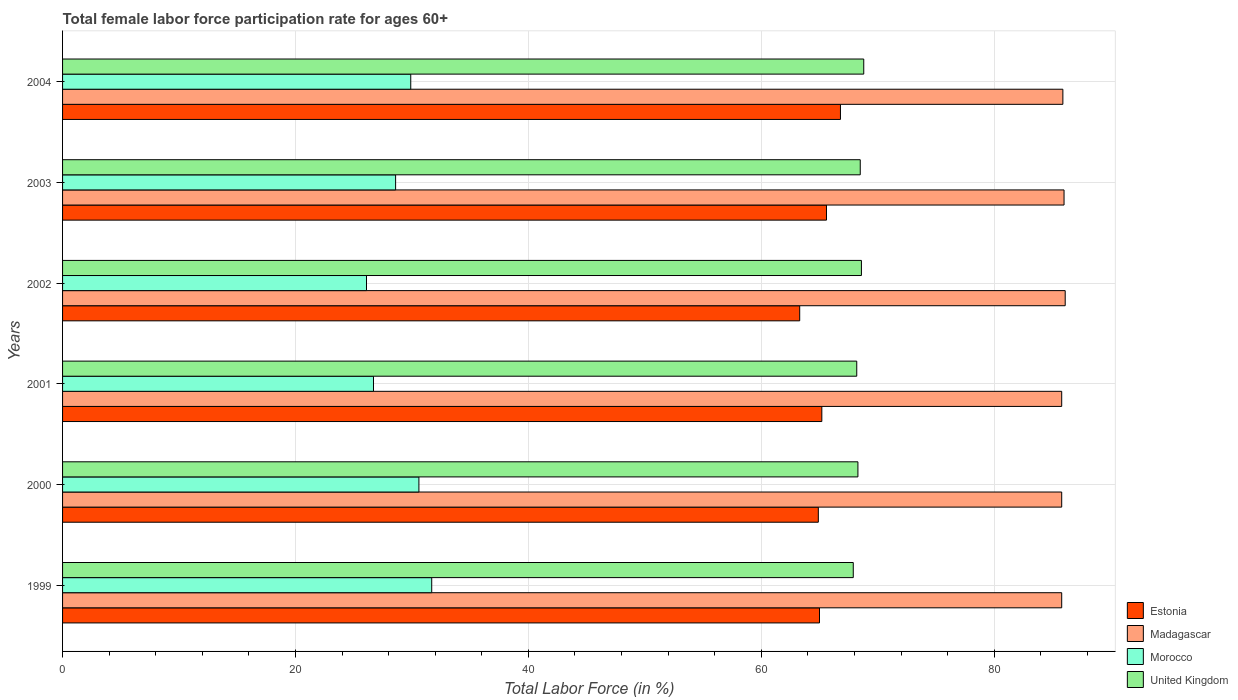Are the number of bars per tick equal to the number of legend labels?
Offer a very short reply. Yes. Are the number of bars on each tick of the Y-axis equal?
Provide a short and direct response. Yes. What is the label of the 5th group of bars from the top?
Your answer should be very brief. 2000. What is the female labor force participation rate in Morocco in 2001?
Your response must be concise. 26.7. Across all years, what is the maximum female labor force participation rate in United Kingdom?
Your answer should be very brief. 68.8. Across all years, what is the minimum female labor force participation rate in Morocco?
Your response must be concise. 26.1. In which year was the female labor force participation rate in Morocco minimum?
Keep it short and to the point. 2002. What is the total female labor force participation rate in Estonia in the graph?
Offer a terse response. 390.8. What is the difference between the female labor force participation rate in Madagascar in 1999 and that in 2003?
Make the answer very short. -0.2. What is the average female labor force participation rate in United Kingdom per year?
Make the answer very short. 68.38. In the year 2000, what is the difference between the female labor force participation rate in Morocco and female labor force participation rate in Madagascar?
Your answer should be very brief. -55.2. What is the ratio of the female labor force participation rate in United Kingdom in 1999 to that in 2000?
Your response must be concise. 0.99. Is the female labor force participation rate in Estonia in 2000 less than that in 2001?
Offer a very short reply. Yes. Is the difference between the female labor force participation rate in Morocco in 2000 and 2003 greater than the difference between the female labor force participation rate in Madagascar in 2000 and 2003?
Your answer should be very brief. Yes. What is the difference between the highest and the second highest female labor force participation rate in Madagascar?
Your answer should be compact. 0.1. What is the difference between the highest and the lowest female labor force participation rate in Morocco?
Ensure brevity in your answer.  5.6. In how many years, is the female labor force participation rate in Morocco greater than the average female labor force participation rate in Morocco taken over all years?
Give a very brief answer. 3. Is it the case that in every year, the sum of the female labor force participation rate in United Kingdom and female labor force participation rate in Madagascar is greater than the sum of female labor force participation rate in Morocco and female labor force participation rate in Estonia?
Provide a short and direct response. No. What does the 3rd bar from the top in 2001 represents?
Provide a short and direct response. Madagascar. What does the 1st bar from the bottom in 1999 represents?
Ensure brevity in your answer.  Estonia. Is it the case that in every year, the sum of the female labor force participation rate in Morocco and female labor force participation rate in United Kingdom is greater than the female labor force participation rate in Madagascar?
Make the answer very short. Yes. How many bars are there?
Your response must be concise. 24. Are all the bars in the graph horizontal?
Offer a terse response. Yes. How many years are there in the graph?
Provide a short and direct response. 6. What is the difference between two consecutive major ticks on the X-axis?
Offer a terse response. 20. Where does the legend appear in the graph?
Your answer should be compact. Bottom right. How many legend labels are there?
Keep it short and to the point. 4. How are the legend labels stacked?
Your response must be concise. Vertical. What is the title of the graph?
Ensure brevity in your answer.  Total female labor force participation rate for ages 60+. Does "Fragile and conflict affected situations" appear as one of the legend labels in the graph?
Give a very brief answer. No. What is the label or title of the X-axis?
Offer a very short reply. Total Labor Force (in %). What is the Total Labor Force (in %) of Estonia in 1999?
Ensure brevity in your answer.  65. What is the Total Labor Force (in %) in Madagascar in 1999?
Give a very brief answer. 85.8. What is the Total Labor Force (in %) of Morocco in 1999?
Provide a succinct answer. 31.7. What is the Total Labor Force (in %) in United Kingdom in 1999?
Keep it short and to the point. 67.9. What is the Total Labor Force (in %) of Estonia in 2000?
Provide a short and direct response. 64.9. What is the Total Labor Force (in %) in Madagascar in 2000?
Provide a succinct answer. 85.8. What is the Total Labor Force (in %) in Morocco in 2000?
Offer a very short reply. 30.6. What is the Total Labor Force (in %) of United Kingdom in 2000?
Give a very brief answer. 68.3. What is the Total Labor Force (in %) in Estonia in 2001?
Make the answer very short. 65.2. What is the Total Labor Force (in %) of Madagascar in 2001?
Your answer should be compact. 85.8. What is the Total Labor Force (in %) in Morocco in 2001?
Offer a terse response. 26.7. What is the Total Labor Force (in %) in United Kingdom in 2001?
Give a very brief answer. 68.2. What is the Total Labor Force (in %) of Estonia in 2002?
Your answer should be compact. 63.3. What is the Total Labor Force (in %) of Madagascar in 2002?
Provide a succinct answer. 86.1. What is the Total Labor Force (in %) of Morocco in 2002?
Your answer should be very brief. 26.1. What is the Total Labor Force (in %) of United Kingdom in 2002?
Provide a succinct answer. 68.6. What is the Total Labor Force (in %) of Estonia in 2003?
Give a very brief answer. 65.6. What is the Total Labor Force (in %) of Madagascar in 2003?
Your answer should be very brief. 86. What is the Total Labor Force (in %) in Morocco in 2003?
Your answer should be compact. 28.6. What is the Total Labor Force (in %) in United Kingdom in 2003?
Provide a succinct answer. 68.5. What is the Total Labor Force (in %) in Estonia in 2004?
Offer a very short reply. 66.8. What is the Total Labor Force (in %) in Madagascar in 2004?
Offer a very short reply. 85.9. What is the Total Labor Force (in %) in Morocco in 2004?
Offer a very short reply. 29.9. What is the Total Labor Force (in %) of United Kingdom in 2004?
Your answer should be very brief. 68.8. Across all years, what is the maximum Total Labor Force (in %) of Estonia?
Offer a very short reply. 66.8. Across all years, what is the maximum Total Labor Force (in %) in Madagascar?
Give a very brief answer. 86.1. Across all years, what is the maximum Total Labor Force (in %) in Morocco?
Keep it short and to the point. 31.7. Across all years, what is the maximum Total Labor Force (in %) in United Kingdom?
Your answer should be compact. 68.8. Across all years, what is the minimum Total Labor Force (in %) in Estonia?
Ensure brevity in your answer.  63.3. Across all years, what is the minimum Total Labor Force (in %) of Madagascar?
Your response must be concise. 85.8. Across all years, what is the minimum Total Labor Force (in %) in Morocco?
Ensure brevity in your answer.  26.1. Across all years, what is the minimum Total Labor Force (in %) in United Kingdom?
Offer a very short reply. 67.9. What is the total Total Labor Force (in %) of Estonia in the graph?
Your answer should be very brief. 390.8. What is the total Total Labor Force (in %) of Madagascar in the graph?
Your response must be concise. 515.4. What is the total Total Labor Force (in %) in Morocco in the graph?
Offer a very short reply. 173.6. What is the total Total Labor Force (in %) of United Kingdom in the graph?
Your answer should be compact. 410.3. What is the difference between the Total Labor Force (in %) in Estonia in 1999 and that in 2000?
Offer a very short reply. 0.1. What is the difference between the Total Labor Force (in %) of Madagascar in 1999 and that in 2000?
Give a very brief answer. 0. What is the difference between the Total Labor Force (in %) in Morocco in 1999 and that in 2000?
Provide a short and direct response. 1.1. What is the difference between the Total Labor Force (in %) of Estonia in 1999 and that in 2002?
Provide a succinct answer. 1.7. What is the difference between the Total Labor Force (in %) of Madagascar in 1999 and that in 2002?
Offer a very short reply. -0.3. What is the difference between the Total Labor Force (in %) of United Kingdom in 1999 and that in 2002?
Offer a very short reply. -0.7. What is the difference between the Total Labor Force (in %) of Estonia in 1999 and that in 2003?
Provide a succinct answer. -0.6. What is the difference between the Total Labor Force (in %) of Madagascar in 1999 and that in 2003?
Ensure brevity in your answer.  -0.2. What is the difference between the Total Labor Force (in %) in Morocco in 1999 and that in 2003?
Your response must be concise. 3.1. What is the difference between the Total Labor Force (in %) of Estonia in 1999 and that in 2004?
Ensure brevity in your answer.  -1.8. What is the difference between the Total Labor Force (in %) in United Kingdom in 1999 and that in 2004?
Your response must be concise. -0.9. What is the difference between the Total Labor Force (in %) in Estonia in 2000 and that in 2001?
Your response must be concise. -0.3. What is the difference between the Total Labor Force (in %) of Madagascar in 2000 and that in 2001?
Your answer should be compact. 0. What is the difference between the Total Labor Force (in %) of Morocco in 2000 and that in 2001?
Provide a succinct answer. 3.9. What is the difference between the Total Labor Force (in %) in Madagascar in 2000 and that in 2002?
Offer a terse response. -0.3. What is the difference between the Total Labor Force (in %) in Morocco in 2000 and that in 2002?
Your response must be concise. 4.5. What is the difference between the Total Labor Force (in %) of United Kingdom in 2000 and that in 2002?
Your answer should be compact. -0.3. What is the difference between the Total Labor Force (in %) in Estonia in 2000 and that in 2003?
Make the answer very short. -0.7. What is the difference between the Total Labor Force (in %) of Madagascar in 2000 and that in 2003?
Ensure brevity in your answer.  -0.2. What is the difference between the Total Labor Force (in %) of Estonia in 2000 and that in 2004?
Offer a terse response. -1.9. What is the difference between the Total Labor Force (in %) of Madagascar in 2000 and that in 2004?
Keep it short and to the point. -0.1. What is the difference between the Total Labor Force (in %) in Morocco in 2000 and that in 2004?
Your answer should be very brief. 0.7. What is the difference between the Total Labor Force (in %) of United Kingdom in 2000 and that in 2004?
Give a very brief answer. -0.5. What is the difference between the Total Labor Force (in %) in Madagascar in 2001 and that in 2002?
Keep it short and to the point. -0.3. What is the difference between the Total Labor Force (in %) in Morocco in 2001 and that in 2002?
Your response must be concise. 0.6. What is the difference between the Total Labor Force (in %) in United Kingdom in 2001 and that in 2002?
Ensure brevity in your answer.  -0.4. What is the difference between the Total Labor Force (in %) of Estonia in 2001 and that in 2003?
Your answer should be very brief. -0.4. What is the difference between the Total Labor Force (in %) in Madagascar in 2001 and that in 2003?
Your answer should be very brief. -0.2. What is the difference between the Total Labor Force (in %) in United Kingdom in 2001 and that in 2003?
Provide a short and direct response. -0.3. What is the difference between the Total Labor Force (in %) of Madagascar in 2001 and that in 2004?
Your response must be concise. -0.1. What is the difference between the Total Labor Force (in %) of Morocco in 2001 and that in 2004?
Ensure brevity in your answer.  -3.2. What is the difference between the Total Labor Force (in %) of United Kingdom in 2001 and that in 2004?
Keep it short and to the point. -0.6. What is the difference between the Total Labor Force (in %) in United Kingdom in 2002 and that in 2003?
Keep it short and to the point. 0.1. What is the difference between the Total Labor Force (in %) of Estonia in 2002 and that in 2004?
Your answer should be compact. -3.5. What is the difference between the Total Labor Force (in %) of Estonia in 2003 and that in 2004?
Give a very brief answer. -1.2. What is the difference between the Total Labor Force (in %) of Morocco in 2003 and that in 2004?
Keep it short and to the point. -1.3. What is the difference between the Total Labor Force (in %) of Estonia in 1999 and the Total Labor Force (in %) of Madagascar in 2000?
Offer a very short reply. -20.8. What is the difference between the Total Labor Force (in %) in Estonia in 1999 and the Total Labor Force (in %) in Morocco in 2000?
Make the answer very short. 34.4. What is the difference between the Total Labor Force (in %) of Estonia in 1999 and the Total Labor Force (in %) of United Kingdom in 2000?
Your response must be concise. -3.3. What is the difference between the Total Labor Force (in %) in Madagascar in 1999 and the Total Labor Force (in %) in Morocco in 2000?
Keep it short and to the point. 55.2. What is the difference between the Total Labor Force (in %) in Morocco in 1999 and the Total Labor Force (in %) in United Kingdom in 2000?
Your response must be concise. -36.6. What is the difference between the Total Labor Force (in %) of Estonia in 1999 and the Total Labor Force (in %) of Madagascar in 2001?
Provide a short and direct response. -20.8. What is the difference between the Total Labor Force (in %) in Estonia in 1999 and the Total Labor Force (in %) in Morocco in 2001?
Your answer should be very brief. 38.3. What is the difference between the Total Labor Force (in %) in Madagascar in 1999 and the Total Labor Force (in %) in Morocco in 2001?
Provide a succinct answer. 59.1. What is the difference between the Total Labor Force (in %) in Madagascar in 1999 and the Total Labor Force (in %) in United Kingdom in 2001?
Your response must be concise. 17.6. What is the difference between the Total Labor Force (in %) of Morocco in 1999 and the Total Labor Force (in %) of United Kingdom in 2001?
Make the answer very short. -36.5. What is the difference between the Total Labor Force (in %) in Estonia in 1999 and the Total Labor Force (in %) in Madagascar in 2002?
Offer a very short reply. -21.1. What is the difference between the Total Labor Force (in %) of Estonia in 1999 and the Total Labor Force (in %) of Morocco in 2002?
Your answer should be compact. 38.9. What is the difference between the Total Labor Force (in %) of Estonia in 1999 and the Total Labor Force (in %) of United Kingdom in 2002?
Keep it short and to the point. -3.6. What is the difference between the Total Labor Force (in %) in Madagascar in 1999 and the Total Labor Force (in %) in Morocco in 2002?
Keep it short and to the point. 59.7. What is the difference between the Total Labor Force (in %) of Madagascar in 1999 and the Total Labor Force (in %) of United Kingdom in 2002?
Make the answer very short. 17.2. What is the difference between the Total Labor Force (in %) of Morocco in 1999 and the Total Labor Force (in %) of United Kingdom in 2002?
Provide a succinct answer. -36.9. What is the difference between the Total Labor Force (in %) of Estonia in 1999 and the Total Labor Force (in %) of Madagascar in 2003?
Keep it short and to the point. -21. What is the difference between the Total Labor Force (in %) in Estonia in 1999 and the Total Labor Force (in %) in Morocco in 2003?
Ensure brevity in your answer.  36.4. What is the difference between the Total Labor Force (in %) in Estonia in 1999 and the Total Labor Force (in %) in United Kingdom in 2003?
Ensure brevity in your answer.  -3.5. What is the difference between the Total Labor Force (in %) of Madagascar in 1999 and the Total Labor Force (in %) of Morocco in 2003?
Make the answer very short. 57.2. What is the difference between the Total Labor Force (in %) of Madagascar in 1999 and the Total Labor Force (in %) of United Kingdom in 2003?
Provide a succinct answer. 17.3. What is the difference between the Total Labor Force (in %) of Morocco in 1999 and the Total Labor Force (in %) of United Kingdom in 2003?
Give a very brief answer. -36.8. What is the difference between the Total Labor Force (in %) in Estonia in 1999 and the Total Labor Force (in %) in Madagascar in 2004?
Offer a terse response. -20.9. What is the difference between the Total Labor Force (in %) in Estonia in 1999 and the Total Labor Force (in %) in Morocco in 2004?
Offer a terse response. 35.1. What is the difference between the Total Labor Force (in %) in Estonia in 1999 and the Total Labor Force (in %) in United Kingdom in 2004?
Your answer should be compact. -3.8. What is the difference between the Total Labor Force (in %) of Madagascar in 1999 and the Total Labor Force (in %) of Morocco in 2004?
Provide a short and direct response. 55.9. What is the difference between the Total Labor Force (in %) in Morocco in 1999 and the Total Labor Force (in %) in United Kingdom in 2004?
Provide a succinct answer. -37.1. What is the difference between the Total Labor Force (in %) in Estonia in 2000 and the Total Labor Force (in %) in Madagascar in 2001?
Offer a terse response. -20.9. What is the difference between the Total Labor Force (in %) of Estonia in 2000 and the Total Labor Force (in %) of Morocco in 2001?
Offer a very short reply. 38.2. What is the difference between the Total Labor Force (in %) of Estonia in 2000 and the Total Labor Force (in %) of United Kingdom in 2001?
Offer a very short reply. -3.3. What is the difference between the Total Labor Force (in %) of Madagascar in 2000 and the Total Labor Force (in %) of Morocco in 2001?
Offer a terse response. 59.1. What is the difference between the Total Labor Force (in %) of Madagascar in 2000 and the Total Labor Force (in %) of United Kingdom in 2001?
Your response must be concise. 17.6. What is the difference between the Total Labor Force (in %) of Morocco in 2000 and the Total Labor Force (in %) of United Kingdom in 2001?
Offer a terse response. -37.6. What is the difference between the Total Labor Force (in %) in Estonia in 2000 and the Total Labor Force (in %) in Madagascar in 2002?
Make the answer very short. -21.2. What is the difference between the Total Labor Force (in %) of Estonia in 2000 and the Total Labor Force (in %) of Morocco in 2002?
Offer a very short reply. 38.8. What is the difference between the Total Labor Force (in %) of Madagascar in 2000 and the Total Labor Force (in %) of Morocco in 2002?
Offer a very short reply. 59.7. What is the difference between the Total Labor Force (in %) of Morocco in 2000 and the Total Labor Force (in %) of United Kingdom in 2002?
Ensure brevity in your answer.  -38. What is the difference between the Total Labor Force (in %) in Estonia in 2000 and the Total Labor Force (in %) in Madagascar in 2003?
Make the answer very short. -21.1. What is the difference between the Total Labor Force (in %) of Estonia in 2000 and the Total Labor Force (in %) of Morocco in 2003?
Your answer should be very brief. 36.3. What is the difference between the Total Labor Force (in %) in Madagascar in 2000 and the Total Labor Force (in %) in Morocco in 2003?
Ensure brevity in your answer.  57.2. What is the difference between the Total Labor Force (in %) of Madagascar in 2000 and the Total Labor Force (in %) of United Kingdom in 2003?
Keep it short and to the point. 17.3. What is the difference between the Total Labor Force (in %) in Morocco in 2000 and the Total Labor Force (in %) in United Kingdom in 2003?
Provide a succinct answer. -37.9. What is the difference between the Total Labor Force (in %) in Madagascar in 2000 and the Total Labor Force (in %) in Morocco in 2004?
Provide a succinct answer. 55.9. What is the difference between the Total Labor Force (in %) of Madagascar in 2000 and the Total Labor Force (in %) of United Kingdom in 2004?
Provide a short and direct response. 17. What is the difference between the Total Labor Force (in %) in Morocco in 2000 and the Total Labor Force (in %) in United Kingdom in 2004?
Your answer should be very brief. -38.2. What is the difference between the Total Labor Force (in %) of Estonia in 2001 and the Total Labor Force (in %) of Madagascar in 2002?
Your answer should be very brief. -20.9. What is the difference between the Total Labor Force (in %) of Estonia in 2001 and the Total Labor Force (in %) of Morocco in 2002?
Ensure brevity in your answer.  39.1. What is the difference between the Total Labor Force (in %) in Estonia in 2001 and the Total Labor Force (in %) in United Kingdom in 2002?
Your answer should be compact. -3.4. What is the difference between the Total Labor Force (in %) in Madagascar in 2001 and the Total Labor Force (in %) in Morocco in 2002?
Offer a very short reply. 59.7. What is the difference between the Total Labor Force (in %) in Madagascar in 2001 and the Total Labor Force (in %) in United Kingdom in 2002?
Give a very brief answer. 17.2. What is the difference between the Total Labor Force (in %) of Morocco in 2001 and the Total Labor Force (in %) of United Kingdom in 2002?
Ensure brevity in your answer.  -41.9. What is the difference between the Total Labor Force (in %) in Estonia in 2001 and the Total Labor Force (in %) in Madagascar in 2003?
Ensure brevity in your answer.  -20.8. What is the difference between the Total Labor Force (in %) of Estonia in 2001 and the Total Labor Force (in %) of Morocco in 2003?
Keep it short and to the point. 36.6. What is the difference between the Total Labor Force (in %) in Estonia in 2001 and the Total Labor Force (in %) in United Kingdom in 2003?
Provide a short and direct response. -3.3. What is the difference between the Total Labor Force (in %) in Madagascar in 2001 and the Total Labor Force (in %) in Morocco in 2003?
Your answer should be very brief. 57.2. What is the difference between the Total Labor Force (in %) of Morocco in 2001 and the Total Labor Force (in %) of United Kingdom in 2003?
Ensure brevity in your answer.  -41.8. What is the difference between the Total Labor Force (in %) in Estonia in 2001 and the Total Labor Force (in %) in Madagascar in 2004?
Provide a succinct answer. -20.7. What is the difference between the Total Labor Force (in %) of Estonia in 2001 and the Total Labor Force (in %) of Morocco in 2004?
Provide a succinct answer. 35.3. What is the difference between the Total Labor Force (in %) in Madagascar in 2001 and the Total Labor Force (in %) in Morocco in 2004?
Make the answer very short. 55.9. What is the difference between the Total Labor Force (in %) in Madagascar in 2001 and the Total Labor Force (in %) in United Kingdom in 2004?
Your response must be concise. 17. What is the difference between the Total Labor Force (in %) in Morocco in 2001 and the Total Labor Force (in %) in United Kingdom in 2004?
Offer a terse response. -42.1. What is the difference between the Total Labor Force (in %) in Estonia in 2002 and the Total Labor Force (in %) in Madagascar in 2003?
Give a very brief answer. -22.7. What is the difference between the Total Labor Force (in %) in Estonia in 2002 and the Total Labor Force (in %) in Morocco in 2003?
Provide a short and direct response. 34.7. What is the difference between the Total Labor Force (in %) of Estonia in 2002 and the Total Labor Force (in %) of United Kingdom in 2003?
Provide a short and direct response. -5.2. What is the difference between the Total Labor Force (in %) of Madagascar in 2002 and the Total Labor Force (in %) of Morocco in 2003?
Provide a short and direct response. 57.5. What is the difference between the Total Labor Force (in %) of Madagascar in 2002 and the Total Labor Force (in %) of United Kingdom in 2003?
Give a very brief answer. 17.6. What is the difference between the Total Labor Force (in %) in Morocco in 2002 and the Total Labor Force (in %) in United Kingdom in 2003?
Your answer should be very brief. -42.4. What is the difference between the Total Labor Force (in %) of Estonia in 2002 and the Total Labor Force (in %) of Madagascar in 2004?
Your response must be concise. -22.6. What is the difference between the Total Labor Force (in %) of Estonia in 2002 and the Total Labor Force (in %) of Morocco in 2004?
Provide a succinct answer. 33.4. What is the difference between the Total Labor Force (in %) of Estonia in 2002 and the Total Labor Force (in %) of United Kingdom in 2004?
Offer a terse response. -5.5. What is the difference between the Total Labor Force (in %) in Madagascar in 2002 and the Total Labor Force (in %) in Morocco in 2004?
Your answer should be very brief. 56.2. What is the difference between the Total Labor Force (in %) of Madagascar in 2002 and the Total Labor Force (in %) of United Kingdom in 2004?
Offer a very short reply. 17.3. What is the difference between the Total Labor Force (in %) in Morocco in 2002 and the Total Labor Force (in %) in United Kingdom in 2004?
Provide a short and direct response. -42.7. What is the difference between the Total Labor Force (in %) of Estonia in 2003 and the Total Labor Force (in %) of Madagascar in 2004?
Make the answer very short. -20.3. What is the difference between the Total Labor Force (in %) of Estonia in 2003 and the Total Labor Force (in %) of Morocco in 2004?
Provide a succinct answer. 35.7. What is the difference between the Total Labor Force (in %) of Estonia in 2003 and the Total Labor Force (in %) of United Kingdom in 2004?
Ensure brevity in your answer.  -3.2. What is the difference between the Total Labor Force (in %) of Madagascar in 2003 and the Total Labor Force (in %) of Morocco in 2004?
Your answer should be compact. 56.1. What is the difference between the Total Labor Force (in %) in Morocco in 2003 and the Total Labor Force (in %) in United Kingdom in 2004?
Provide a succinct answer. -40.2. What is the average Total Labor Force (in %) of Estonia per year?
Your answer should be very brief. 65.13. What is the average Total Labor Force (in %) of Madagascar per year?
Offer a terse response. 85.9. What is the average Total Labor Force (in %) in Morocco per year?
Your response must be concise. 28.93. What is the average Total Labor Force (in %) in United Kingdom per year?
Keep it short and to the point. 68.38. In the year 1999, what is the difference between the Total Labor Force (in %) in Estonia and Total Labor Force (in %) in Madagascar?
Keep it short and to the point. -20.8. In the year 1999, what is the difference between the Total Labor Force (in %) in Estonia and Total Labor Force (in %) in Morocco?
Keep it short and to the point. 33.3. In the year 1999, what is the difference between the Total Labor Force (in %) in Madagascar and Total Labor Force (in %) in Morocco?
Offer a terse response. 54.1. In the year 1999, what is the difference between the Total Labor Force (in %) in Madagascar and Total Labor Force (in %) in United Kingdom?
Your response must be concise. 17.9. In the year 1999, what is the difference between the Total Labor Force (in %) in Morocco and Total Labor Force (in %) in United Kingdom?
Offer a very short reply. -36.2. In the year 2000, what is the difference between the Total Labor Force (in %) of Estonia and Total Labor Force (in %) of Madagascar?
Ensure brevity in your answer.  -20.9. In the year 2000, what is the difference between the Total Labor Force (in %) of Estonia and Total Labor Force (in %) of Morocco?
Provide a succinct answer. 34.3. In the year 2000, what is the difference between the Total Labor Force (in %) of Madagascar and Total Labor Force (in %) of Morocco?
Offer a very short reply. 55.2. In the year 2000, what is the difference between the Total Labor Force (in %) in Madagascar and Total Labor Force (in %) in United Kingdom?
Your answer should be very brief. 17.5. In the year 2000, what is the difference between the Total Labor Force (in %) in Morocco and Total Labor Force (in %) in United Kingdom?
Provide a short and direct response. -37.7. In the year 2001, what is the difference between the Total Labor Force (in %) in Estonia and Total Labor Force (in %) in Madagascar?
Give a very brief answer. -20.6. In the year 2001, what is the difference between the Total Labor Force (in %) in Estonia and Total Labor Force (in %) in Morocco?
Ensure brevity in your answer.  38.5. In the year 2001, what is the difference between the Total Labor Force (in %) in Estonia and Total Labor Force (in %) in United Kingdom?
Offer a very short reply. -3. In the year 2001, what is the difference between the Total Labor Force (in %) of Madagascar and Total Labor Force (in %) of Morocco?
Offer a terse response. 59.1. In the year 2001, what is the difference between the Total Labor Force (in %) in Madagascar and Total Labor Force (in %) in United Kingdom?
Your response must be concise. 17.6. In the year 2001, what is the difference between the Total Labor Force (in %) of Morocco and Total Labor Force (in %) of United Kingdom?
Your answer should be very brief. -41.5. In the year 2002, what is the difference between the Total Labor Force (in %) of Estonia and Total Labor Force (in %) of Madagascar?
Offer a very short reply. -22.8. In the year 2002, what is the difference between the Total Labor Force (in %) in Estonia and Total Labor Force (in %) in Morocco?
Offer a very short reply. 37.2. In the year 2002, what is the difference between the Total Labor Force (in %) in Madagascar and Total Labor Force (in %) in Morocco?
Make the answer very short. 60. In the year 2002, what is the difference between the Total Labor Force (in %) in Madagascar and Total Labor Force (in %) in United Kingdom?
Offer a terse response. 17.5. In the year 2002, what is the difference between the Total Labor Force (in %) of Morocco and Total Labor Force (in %) of United Kingdom?
Provide a short and direct response. -42.5. In the year 2003, what is the difference between the Total Labor Force (in %) of Estonia and Total Labor Force (in %) of Madagascar?
Provide a short and direct response. -20.4. In the year 2003, what is the difference between the Total Labor Force (in %) in Estonia and Total Labor Force (in %) in United Kingdom?
Offer a terse response. -2.9. In the year 2003, what is the difference between the Total Labor Force (in %) in Madagascar and Total Labor Force (in %) in Morocco?
Give a very brief answer. 57.4. In the year 2003, what is the difference between the Total Labor Force (in %) in Madagascar and Total Labor Force (in %) in United Kingdom?
Make the answer very short. 17.5. In the year 2003, what is the difference between the Total Labor Force (in %) of Morocco and Total Labor Force (in %) of United Kingdom?
Offer a very short reply. -39.9. In the year 2004, what is the difference between the Total Labor Force (in %) of Estonia and Total Labor Force (in %) of Madagascar?
Provide a short and direct response. -19.1. In the year 2004, what is the difference between the Total Labor Force (in %) of Estonia and Total Labor Force (in %) of Morocco?
Keep it short and to the point. 36.9. In the year 2004, what is the difference between the Total Labor Force (in %) in Madagascar and Total Labor Force (in %) in Morocco?
Ensure brevity in your answer.  56. In the year 2004, what is the difference between the Total Labor Force (in %) of Madagascar and Total Labor Force (in %) of United Kingdom?
Offer a very short reply. 17.1. In the year 2004, what is the difference between the Total Labor Force (in %) of Morocco and Total Labor Force (in %) of United Kingdom?
Ensure brevity in your answer.  -38.9. What is the ratio of the Total Labor Force (in %) in Estonia in 1999 to that in 2000?
Keep it short and to the point. 1. What is the ratio of the Total Labor Force (in %) in Morocco in 1999 to that in 2000?
Your response must be concise. 1.04. What is the ratio of the Total Labor Force (in %) of Estonia in 1999 to that in 2001?
Provide a succinct answer. 1. What is the ratio of the Total Labor Force (in %) of Madagascar in 1999 to that in 2001?
Provide a short and direct response. 1. What is the ratio of the Total Labor Force (in %) in Morocco in 1999 to that in 2001?
Give a very brief answer. 1.19. What is the ratio of the Total Labor Force (in %) of United Kingdom in 1999 to that in 2001?
Your response must be concise. 1. What is the ratio of the Total Labor Force (in %) of Estonia in 1999 to that in 2002?
Your answer should be very brief. 1.03. What is the ratio of the Total Labor Force (in %) in Madagascar in 1999 to that in 2002?
Your answer should be very brief. 1. What is the ratio of the Total Labor Force (in %) of Morocco in 1999 to that in 2002?
Your answer should be compact. 1.21. What is the ratio of the Total Labor Force (in %) of Estonia in 1999 to that in 2003?
Give a very brief answer. 0.99. What is the ratio of the Total Labor Force (in %) in Madagascar in 1999 to that in 2003?
Give a very brief answer. 1. What is the ratio of the Total Labor Force (in %) in Morocco in 1999 to that in 2003?
Offer a very short reply. 1.11. What is the ratio of the Total Labor Force (in %) in Estonia in 1999 to that in 2004?
Ensure brevity in your answer.  0.97. What is the ratio of the Total Labor Force (in %) in Madagascar in 1999 to that in 2004?
Make the answer very short. 1. What is the ratio of the Total Labor Force (in %) of Morocco in 1999 to that in 2004?
Your answer should be compact. 1.06. What is the ratio of the Total Labor Force (in %) in United Kingdom in 1999 to that in 2004?
Offer a very short reply. 0.99. What is the ratio of the Total Labor Force (in %) of Madagascar in 2000 to that in 2001?
Offer a very short reply. 1. What is the ratio of the Total Labor Force (in %) in Morocco in 2000 to that in 2001?
Make the answer very short. 1.15. What is the ratio of the Total Labor Force (in %) in Estonia in 2000 to that in 2002?
Provide a succinct answer. 1.03. What is the ratio of the Total Labor Force (in %) in Morocco in 2000 to that in 2002?
Offer a very short reply. 1.17. What is the ratio of the Total Labor Force (in %) in Estonia in 2000 to that in 2003?
Ensure brevity in your answer.  0.99. What is the ratio of the Total Labor Force (in %) in Morocco in 2000 to that in 2003?
Provide a short and direct response. 1.07. What is the ratio of the Total Labor Force (in %) of Estonia in 2000 to that in 2004?
Provide a short and direct response. 0.97. What is the ratio of the Total Labor Force (in %) in Morocco in 2000 to that in 2004?
Offer a very short reply. 1.02. What is the ratio of the Total Labor Force (in %) of Estonia in 2001 to that in 2002?
Offer a terse response. 1.03. What is the ratio of the Total Labor Force (in %) in Madagascar in 2001 to that in 2002?
Offer a very short reply. 1. What is the ratio of the Total Labor Force (in %) in Morocco in 2001 to that in 2002?
Give a very brief answer. 1.02. What is the ratio of the Total Labor Force (in %) of United Kingdom in 2001 to that in 2002?
Your answer should be compact. 0.99. What is the ratio of the Total Labor Force (in %) of Estonia in 2001 to that in 2003?
Offer a very short reply. 0.99. What is the ratio of the Total Labor Force (in %) of Madagascar in 2001 to that in 2003?
Your answer should be very brief. 1. What is the ratio of the Total Labor Force (in %) of Morocco in 2001 to that in 2003?
Your answer should be compact. 0.93. What is the ratio of the Total Labor Force (in %) in United Kingdom in 2001 to that in 2003?
Make the answer very short. 1. What is the ratio of the Total Labor Force (in %) of Estonia in 2001 to that in 2004?
Provide a short and direct response. 0.98. What is the ratio of the Total Labor Force (in %) in Morocco in 2001 to that in 2004?
Give a very brief answer. 0.89. What is the ratio of the Total Labor Force (in %) in Estonia in 2002 to that in 2003?
Your answer should be compact. 0.96. What is the ratio of the Total Labor Force (in %) in Morocco in 2002 to that in 2003?
Provide a short and direct response. 0.91. What is the ratio of the Total Labor Force (in %) in United Kingdom in 2002 to that in 2003?
Keep it short and to the point. 1. What is the ratio of the Total Labor Force (in %) of Estonia in 2002 to that in 2004?
Make the answer very short. 0.95. What is the ratio of the Total Labor Force (in %) of Morocco in 2002 to that in 2004?
Make the answer very short. 0.87. What is the ratio of the Total Labor Force (in %) in Estonia in 2003 to that in 2004?
Ensure brevity in your answer.  0.98. What is the ratio of the Total Labor Force (in %) in Madagascar in 2003 to that in 2004?
Provide a succinct answer. 1. What is the ratio of the Total Labor Force (in %) of Morocco in 2003 to that in 2004?
Make the answer very short. 0.96. What is the ratio of the Total Labor Force (in %) of United Kingdom in 2003 to that in 2004?
Make the answer very short. 1. What is the difference between the highest and the second highest Total Labor Force (in %) of Estonia?
Make the answer very short. 1.2. What is the difference between the highest and the second highest Total Labor Force (in %) in Madagascar?
Give a very brief answer. 0.1. What is the difference between the highest and the second highest Total Labor Force (in %) in Morocco?
Your response must be concise. 1.1. 